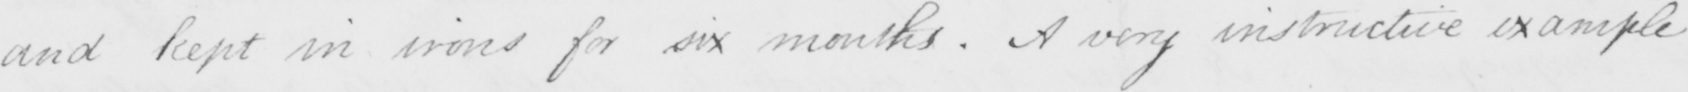What does this handwritten line say? and kept in irons for six months . A very instructive example 